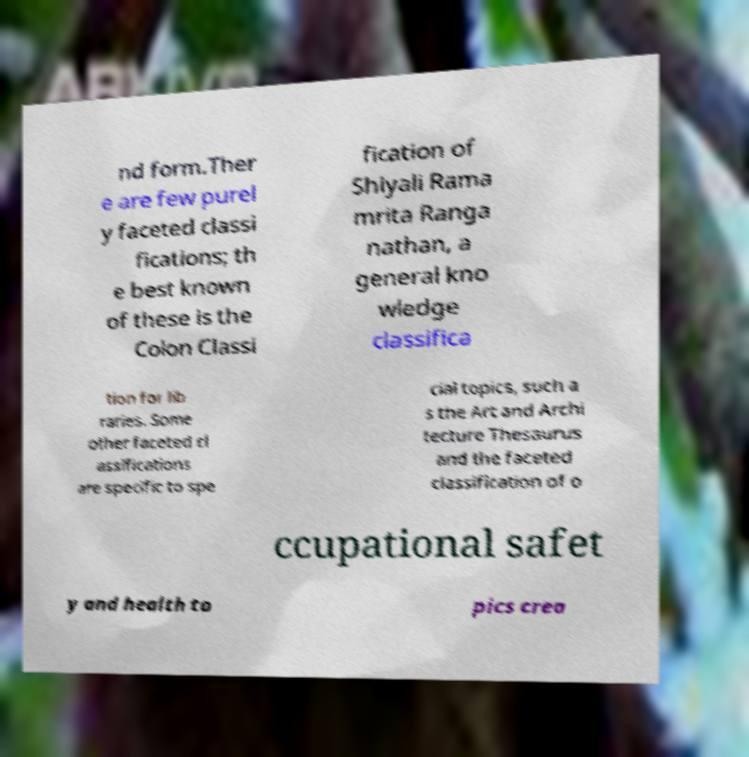Please identify and transcribe the text found in this image. nd form.Ther e are few purel y faceted classi fications; th e best known of these is the Colon Classi fication of Shiyali Rama mrita Ranga nathan, a general kno wledge classifica tion for lib raries. Some other faceted cl assifications are specific to spe cial topics, such a s the Art and Archi tecture Thesaurus and the faceted classification of o ccupational safet y and health to pics crea 